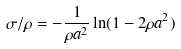<formula> <loc_0><loc_0><loc_500><loc_500>\sigma / \rho = - \frac { 1 } { \rho a ^ { 2 } } \ln ( 1 - 2 \rho a ^ { 2 } )</formula> 